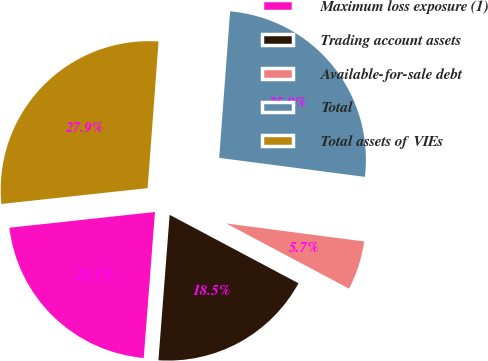<chart> <loc_0><loc_0><loc_500><loc_500><pie_chart><fcel>Maximum loss exposure (1)<fcel>Trading account assets<fcel>Available-for-sale debt<fcel>Total<fcel>Total assets of VIEs<nl><fcel>22.06%<fcel>18.45%<fcel>5.71%<fcel>25.88%<fcel>27.9%<nl></chart> 